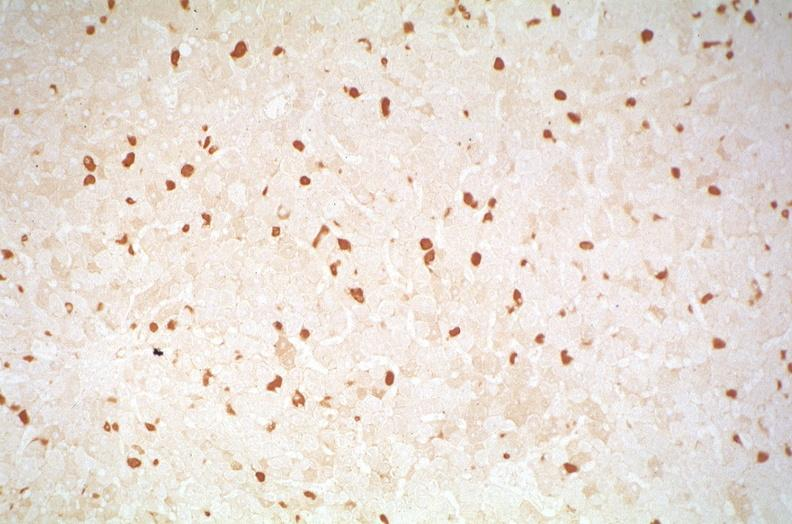s liver present?
Answer the question using a single word or phrase. Yes 